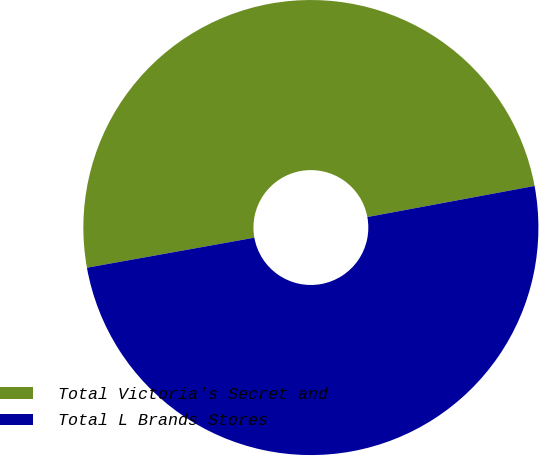<chart> <loc_0><loc_0><loc_500><loc_500><pie_chart><fcel>Total Victoria's Secret and<fcel>Total L Brands Stores<nl><fcel>49.9%<fcel>50.1%<nl></chart> 